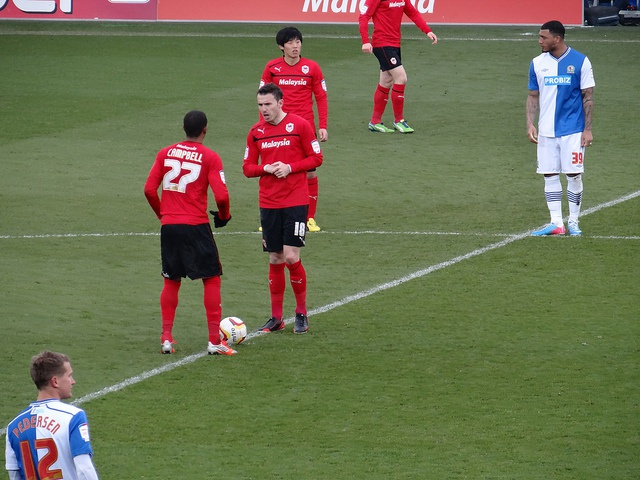Describe the objects in this image and their specific colors. I can see people in lavender, brown, and black tones, people in lavender, black, brown, and olive tones, people in lavender, blue, and gray tones, people in lavender, brown, gray, and black tones, and people in lavender, brown, and black tones in this image. 